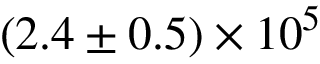Convert formula to latex. <formula><loc_0><loc_0><loc_500><loc_500>( 2 . 4 \pm 0 . 5 ) \times 1 0 ^ { 5 }</formula> 